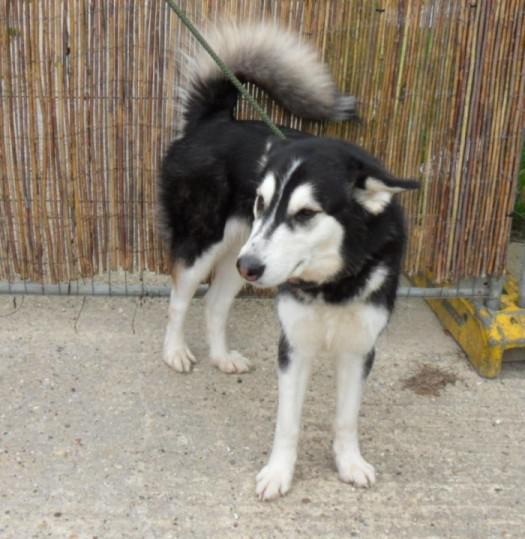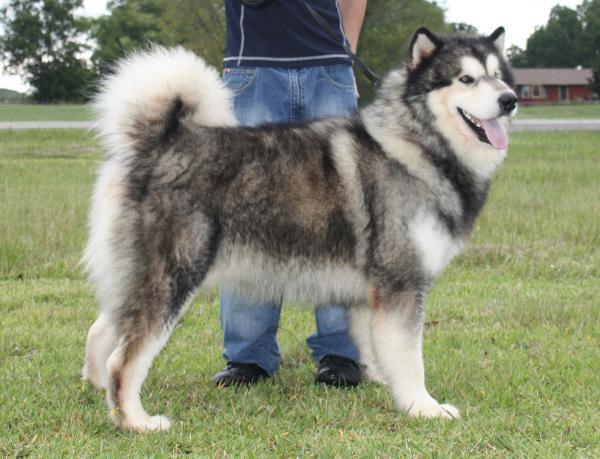The first image is the image on the left, the second image is the image on the right. Given the left and right images, does the statement "The dog in one of the images is standing on the wood planks of a deck outside." hold true? Answer yes or no. No. The first image is the image on the left, the second image is the image on the right. Considering the images on both sides, is "The right image shows a husky standing in profile with its tail curled inward, and the left image shows a dog on a rope in a standing pose in front of an outdoor 'wall'." valid? Answer yes or no. Yes. 